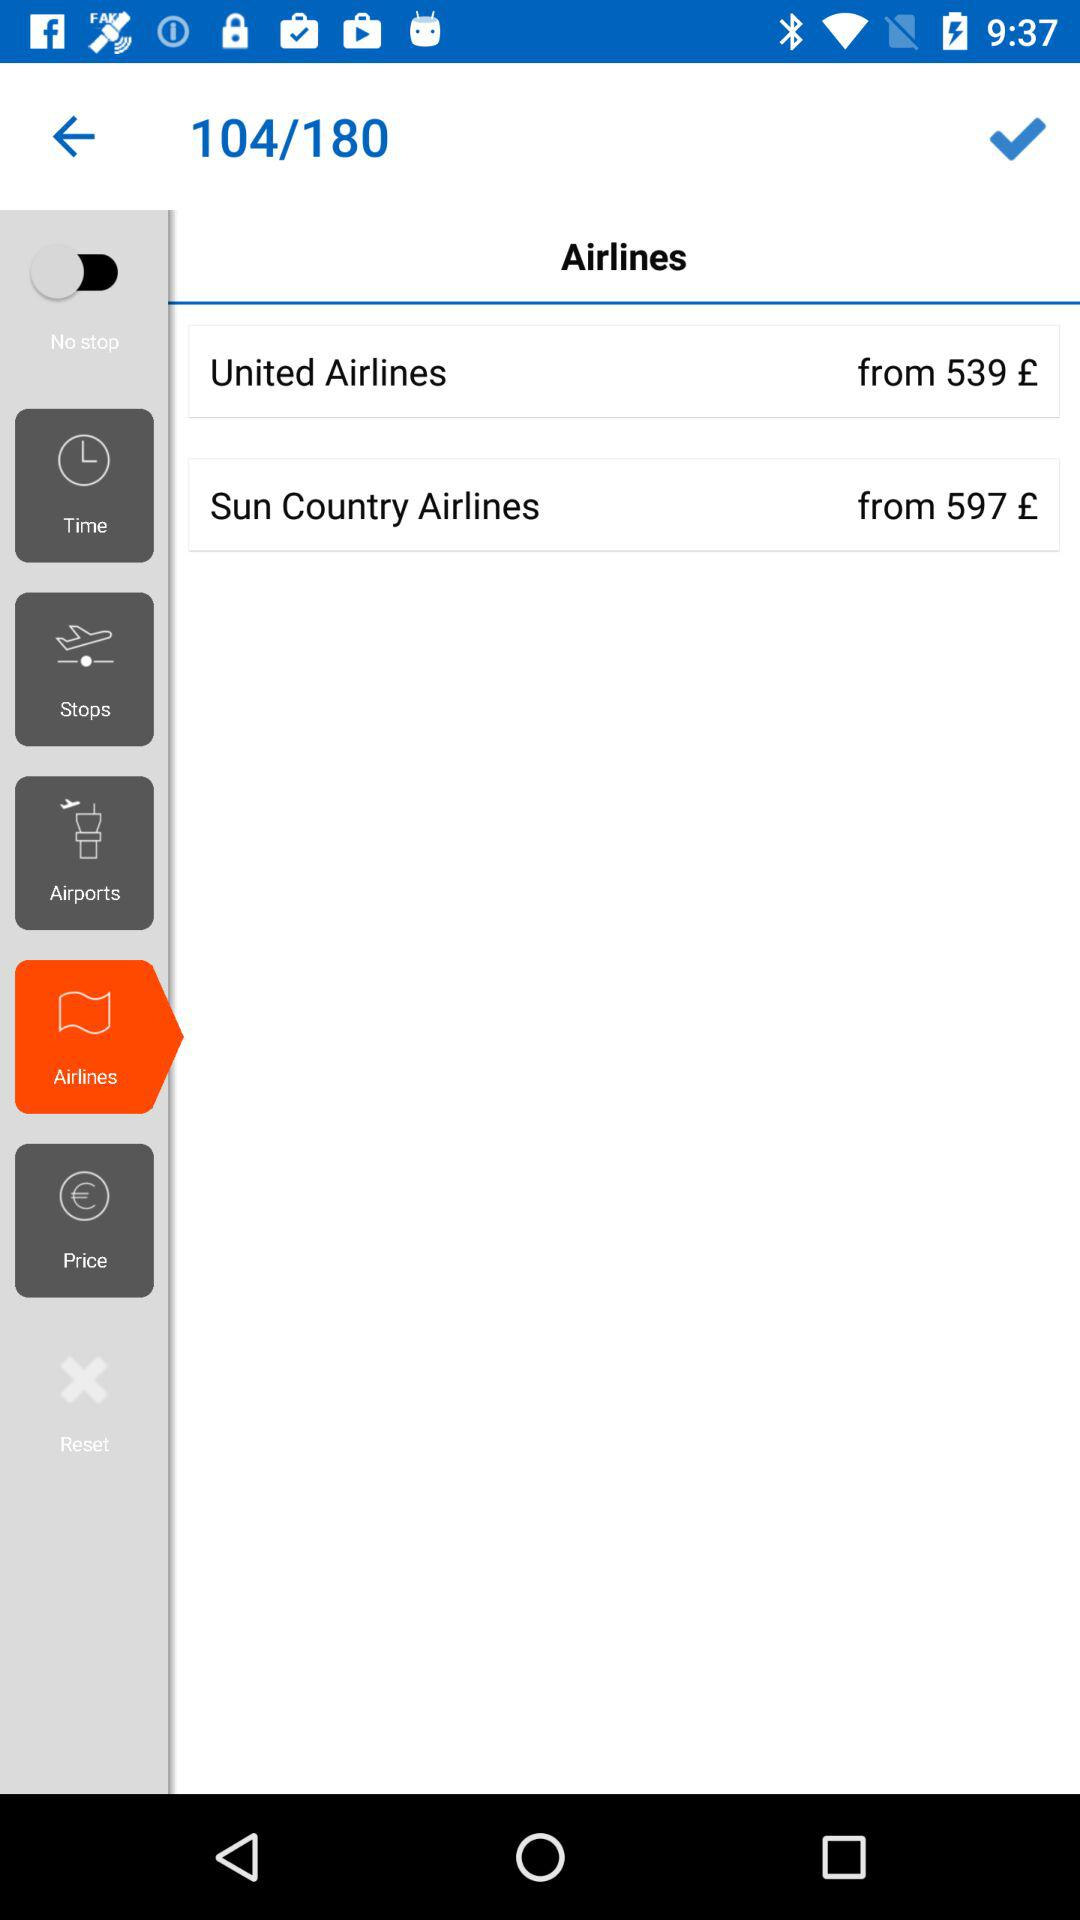Which option is selected? The option "Airlines" is selected. 